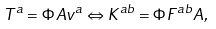Convert formula to latex. <formula><loc_0><loc_0><loc_500><loc_500>T ^ { a } = \Phi A v ^ { a } \Leftrightarrow K ^ { a b } = \Phi F ^ { a b } A ,</formula> 